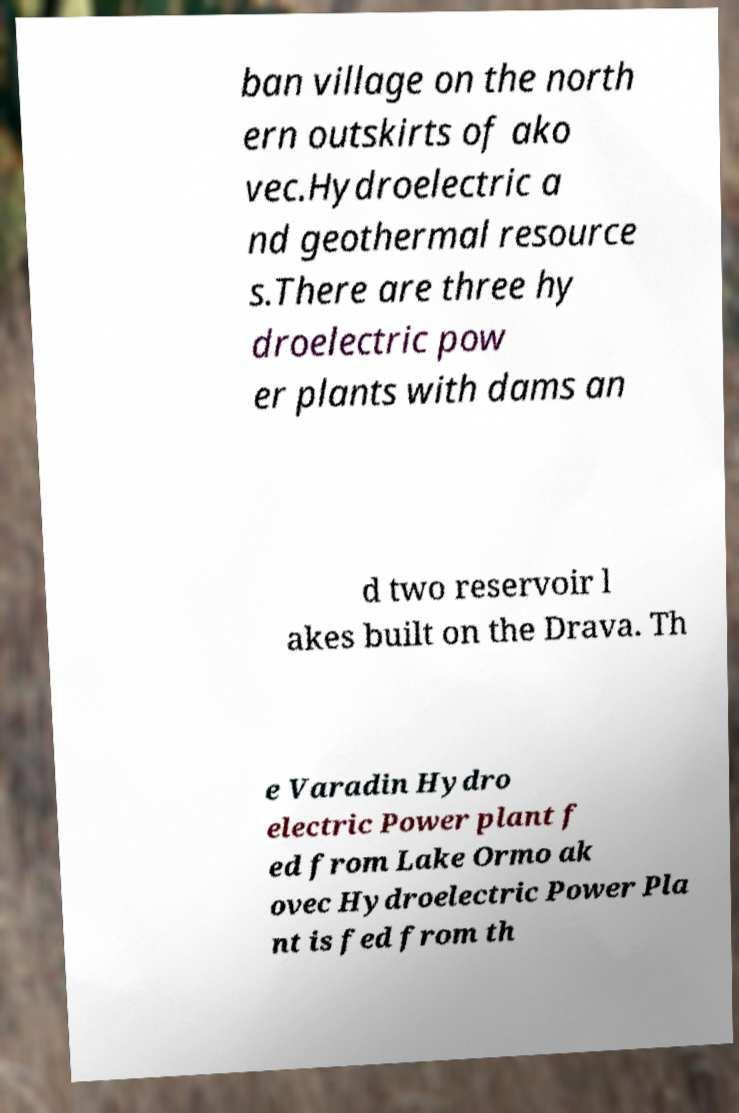There's text embedded in this image that I need extracted. Can you transcribe it verbatim? ban village on the north ern outskirts of ako vec.Hydroelectric a nd geothermal resource s.There are three hy droelectric pow er plants with dams an d two reservoir l akes built on the Drava. Th e Varadin Hydro electric Power plant f ed from Lake Ormo ak ovec Hydroelectric Power Pla nt is fed from th 